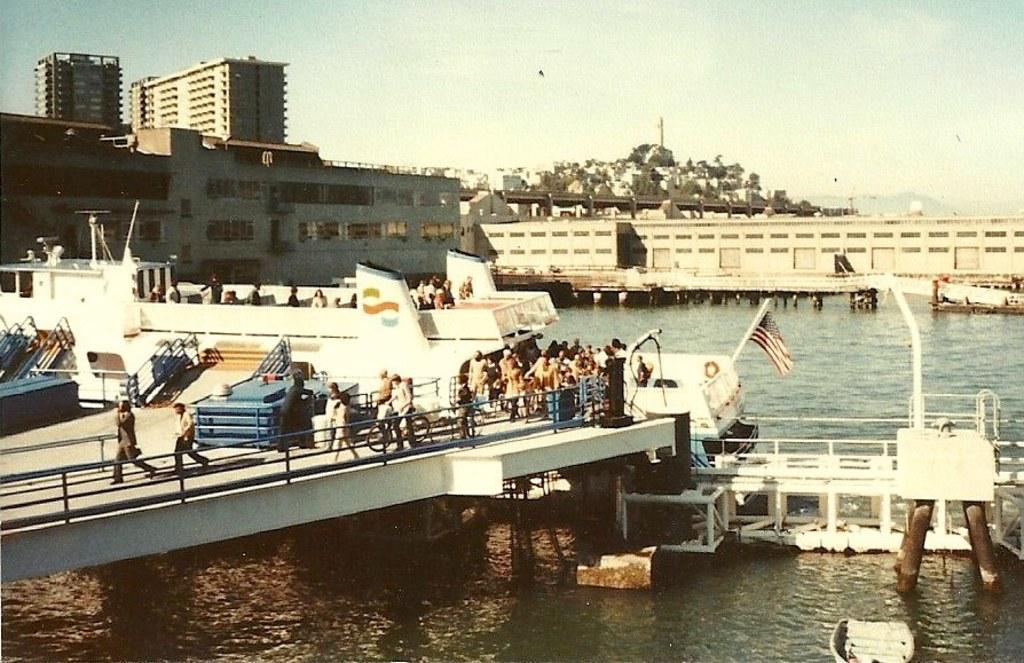Please provide a concise description of this image. In this image I can see few buildings, windows, sky and the water. In front I can see few bridges and on the bridge I can see few people, few objects and the person is holding the bicycle. 